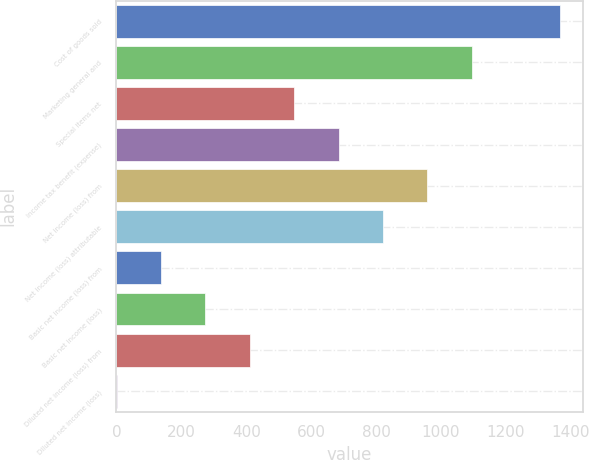Convert chart to OTSL. <chart><loc_0><loc_0><loc_500><loc_500><bar_chart><fcel>Cost of goods sold<fcel>Marketing general and<fcel>Special items net<fcel>Income tax benefit (expense)<fcel>Net income (loss) from<fcel>Net income (loss) attributable<fcel>Basic net income (loss) from<fcel>Basic net income (loss)<fcel>Diluted net income (loss) from<fcel>Diluted net income (loss)<nl><fcel>1367.7<fcel>1094.32<fcel>547.64<fcel>684.31<fcel>957.65<fcel>820.98<fcel>137.63<fcel>274.3<fcel>410.97<fcel>0.96<nl></chart> 